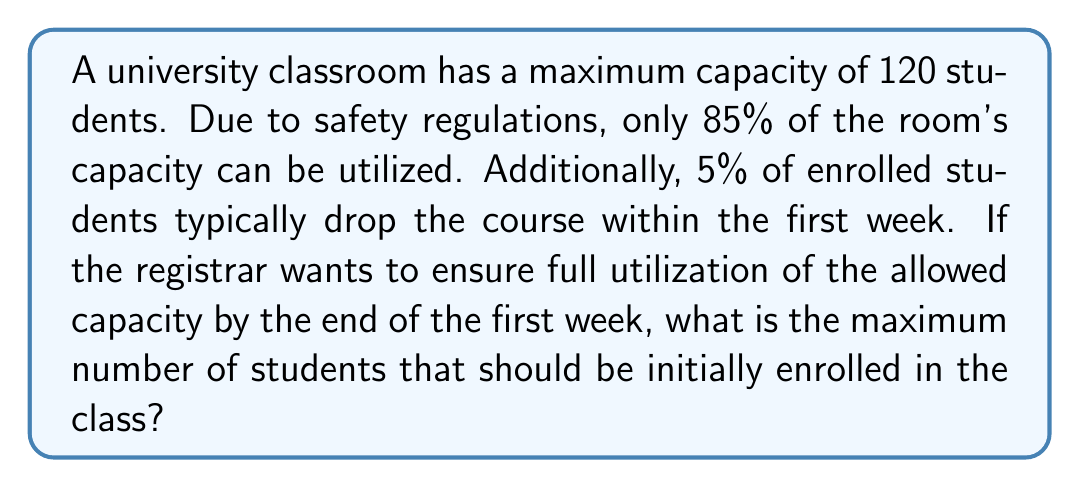Teach me how to tackle this problem. Let's approach this step-by-step:

1. Calculate the usable capacity of the room:
   $$ \text{Usable Capacity} = 120 \times 0.85 = 102 \text{ students} $$

2. Let $x$ be the initial number of students enrolled.

3. After the first week, 95% of the initially enrolled students will remain:
   $$ 0.95x = 102 $$

4. Solve for $x$:
   $$ x = \frac{102}{0.95} \approx 107.37 $$

5. Since we can't enroll a fractional number of students, we need to round down to the nearest whole number.
Answer: 107 students 